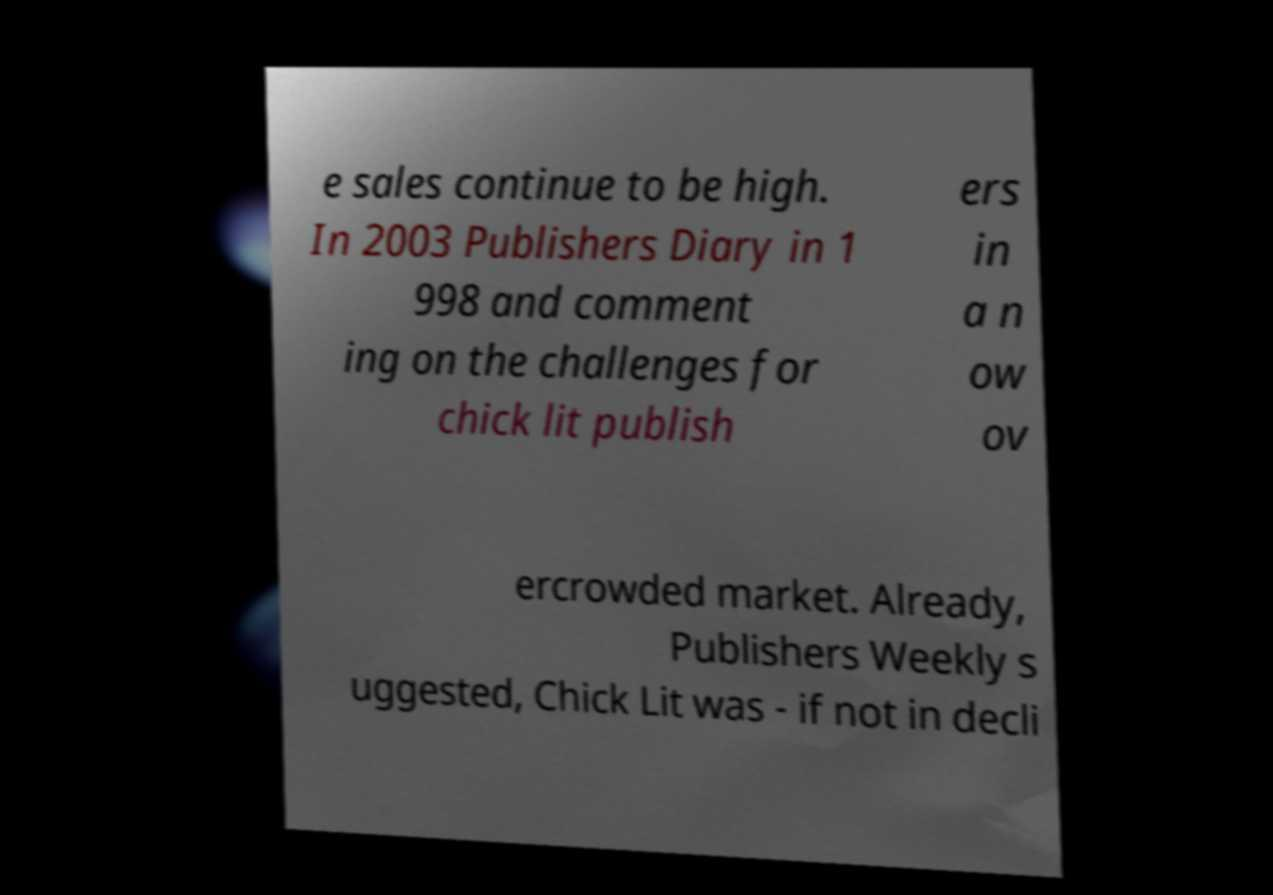There's text embedded in this image that I need extracted. Can you transcribe it verbatim? e sales continue to be high. In 2003 Publishers Diary in 1 998 and comment ing on the challenges for chick lit publish ers in a n ow ov ercrowded market. Already, Publishers Weekly s uggested, Chick Lit was - if not in decli 